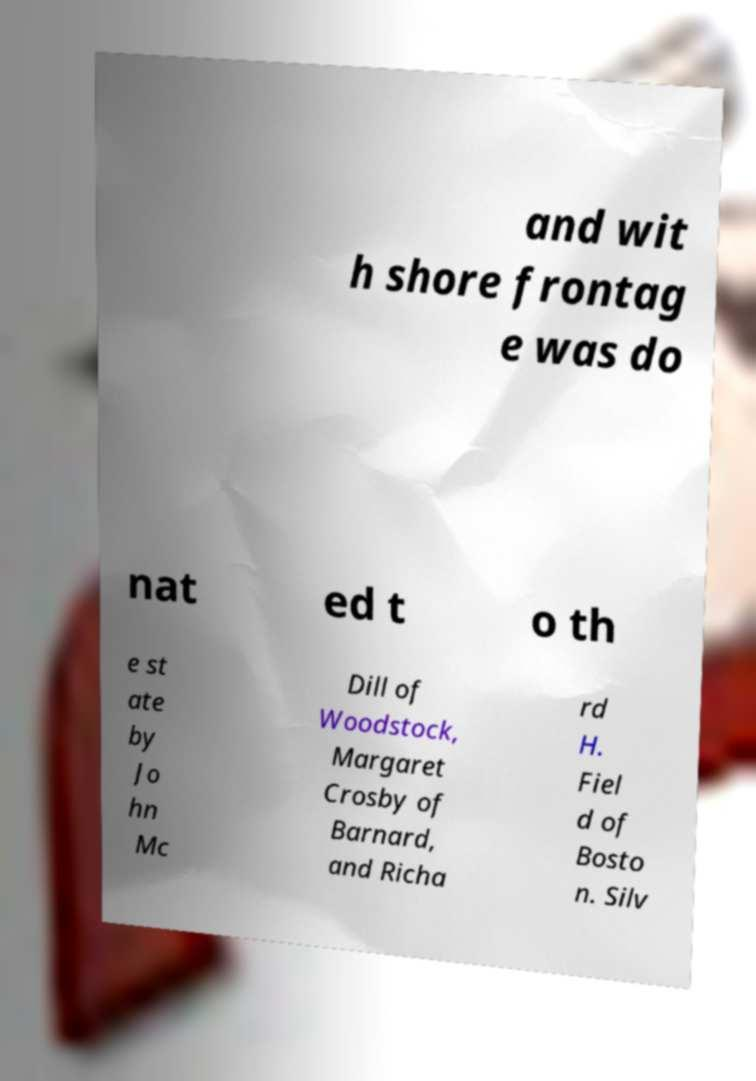Could you extract and type out the text from this image? and wit h shore frontag e was do nat ed t o th e st ate by Jo hn Mc Dill of Woodstock, Margaret Crosby of Barnard, and Richa rd H. Fiel d of Bosto n. Silv 